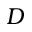<formula> <loc_0><loc_0><loc_500><loc_500>{ D }</formula> 